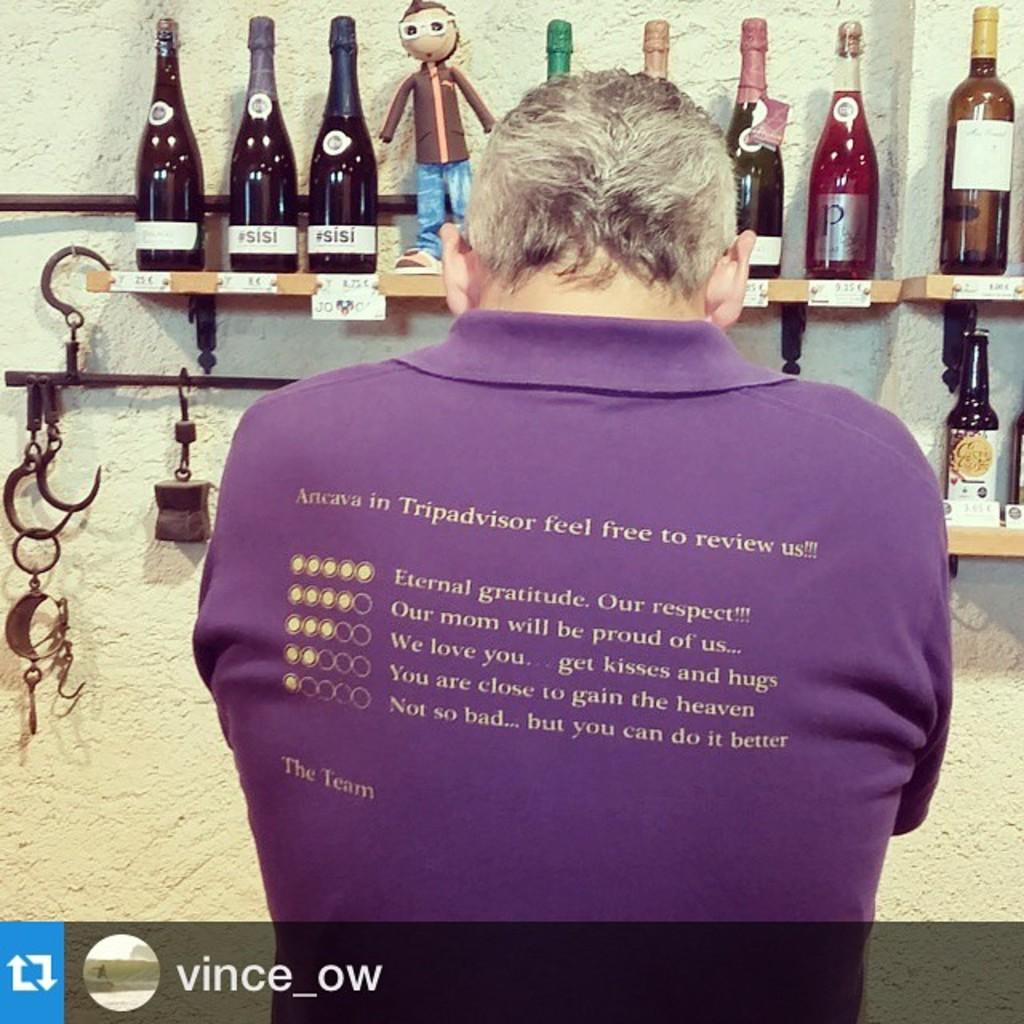Describe this image in one or two sentences. Here we can see a man is standing, and in front here is the wall, and wine bottles attached to it. 